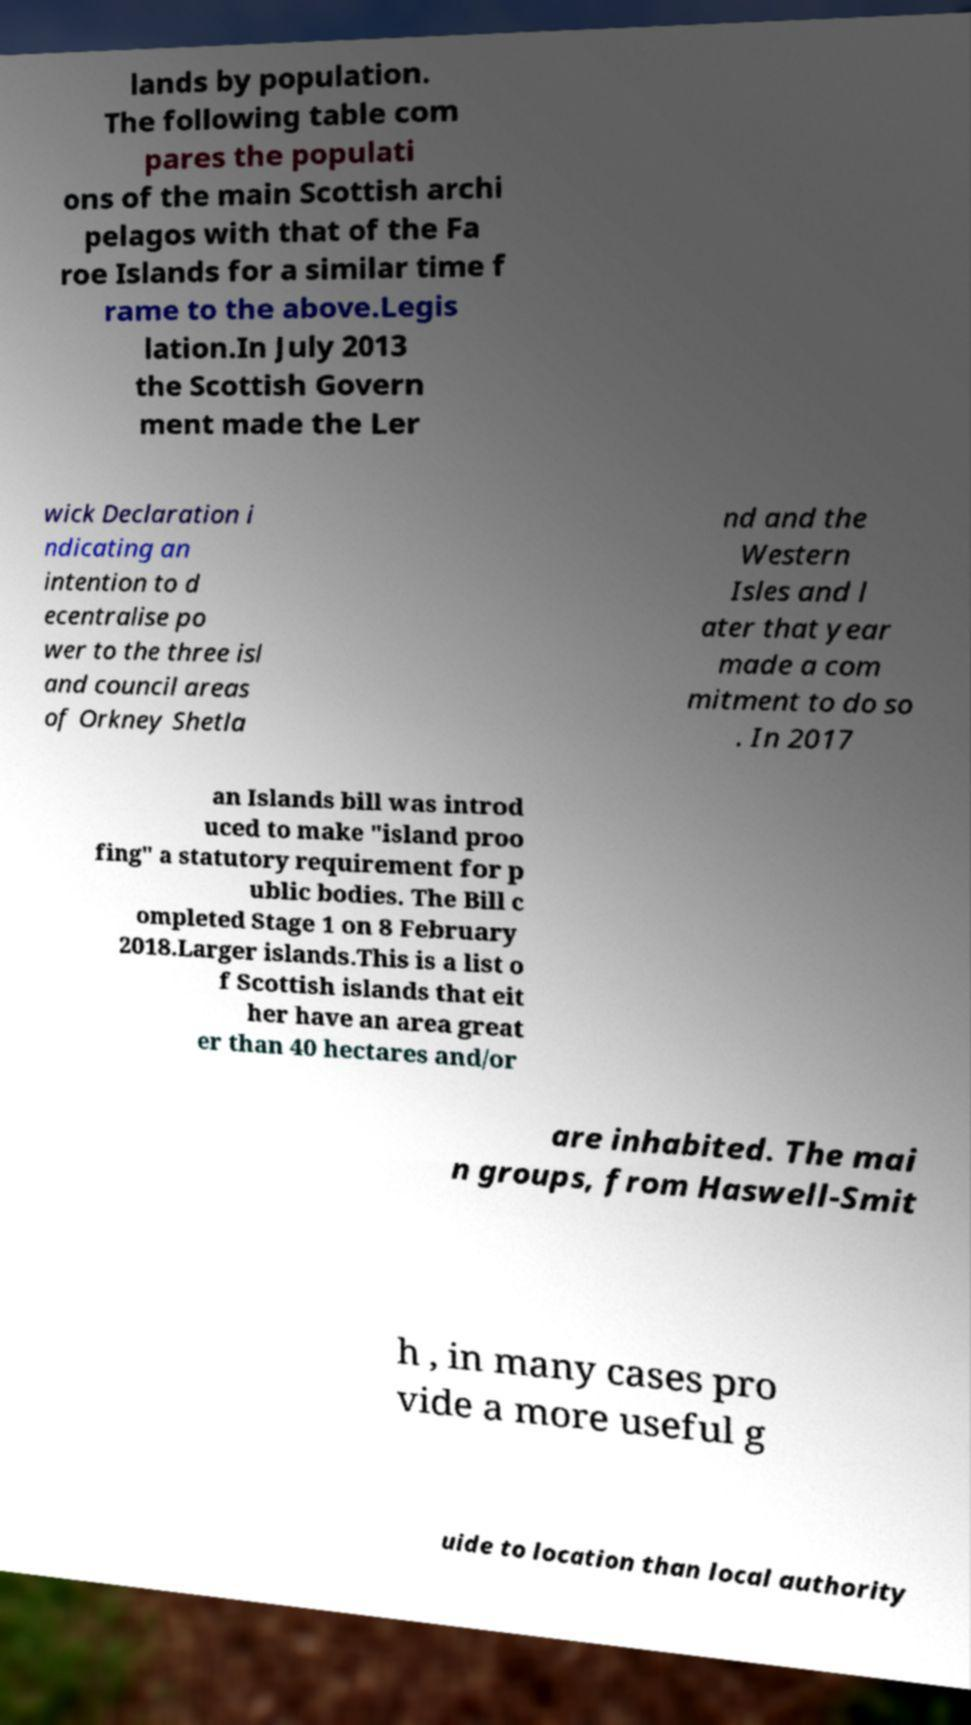Please read and relay the text visible in this image. What does it say? lands by population. The following table com pares the populati ons of the main Scottish archi pelagos with that of the Fa roe Islands for a similar time f rame to the above.Legis lation.In July 2013 the Scottish Govern ment made the Ler wick Declaration i ndicating an intention to d ecentralise po wer to the three isl and council areas of Orkney Shetla nd and the Western Isles and l ater that year made a com mitment to do so . In 2017 an Islands bill was introd uced to make "island proo fing" a statutory requirement for p ublic bodies. The Bill c ompleted Stage 1 on 8 February 2018.Larger islands.This is a list o f Scottish islands that eit her have an area great er than 40 hectares and/or are inhabited. The mai n groups, from Haswell-Smit h , in many cases pro vide a more useful g uide to location than local authority 